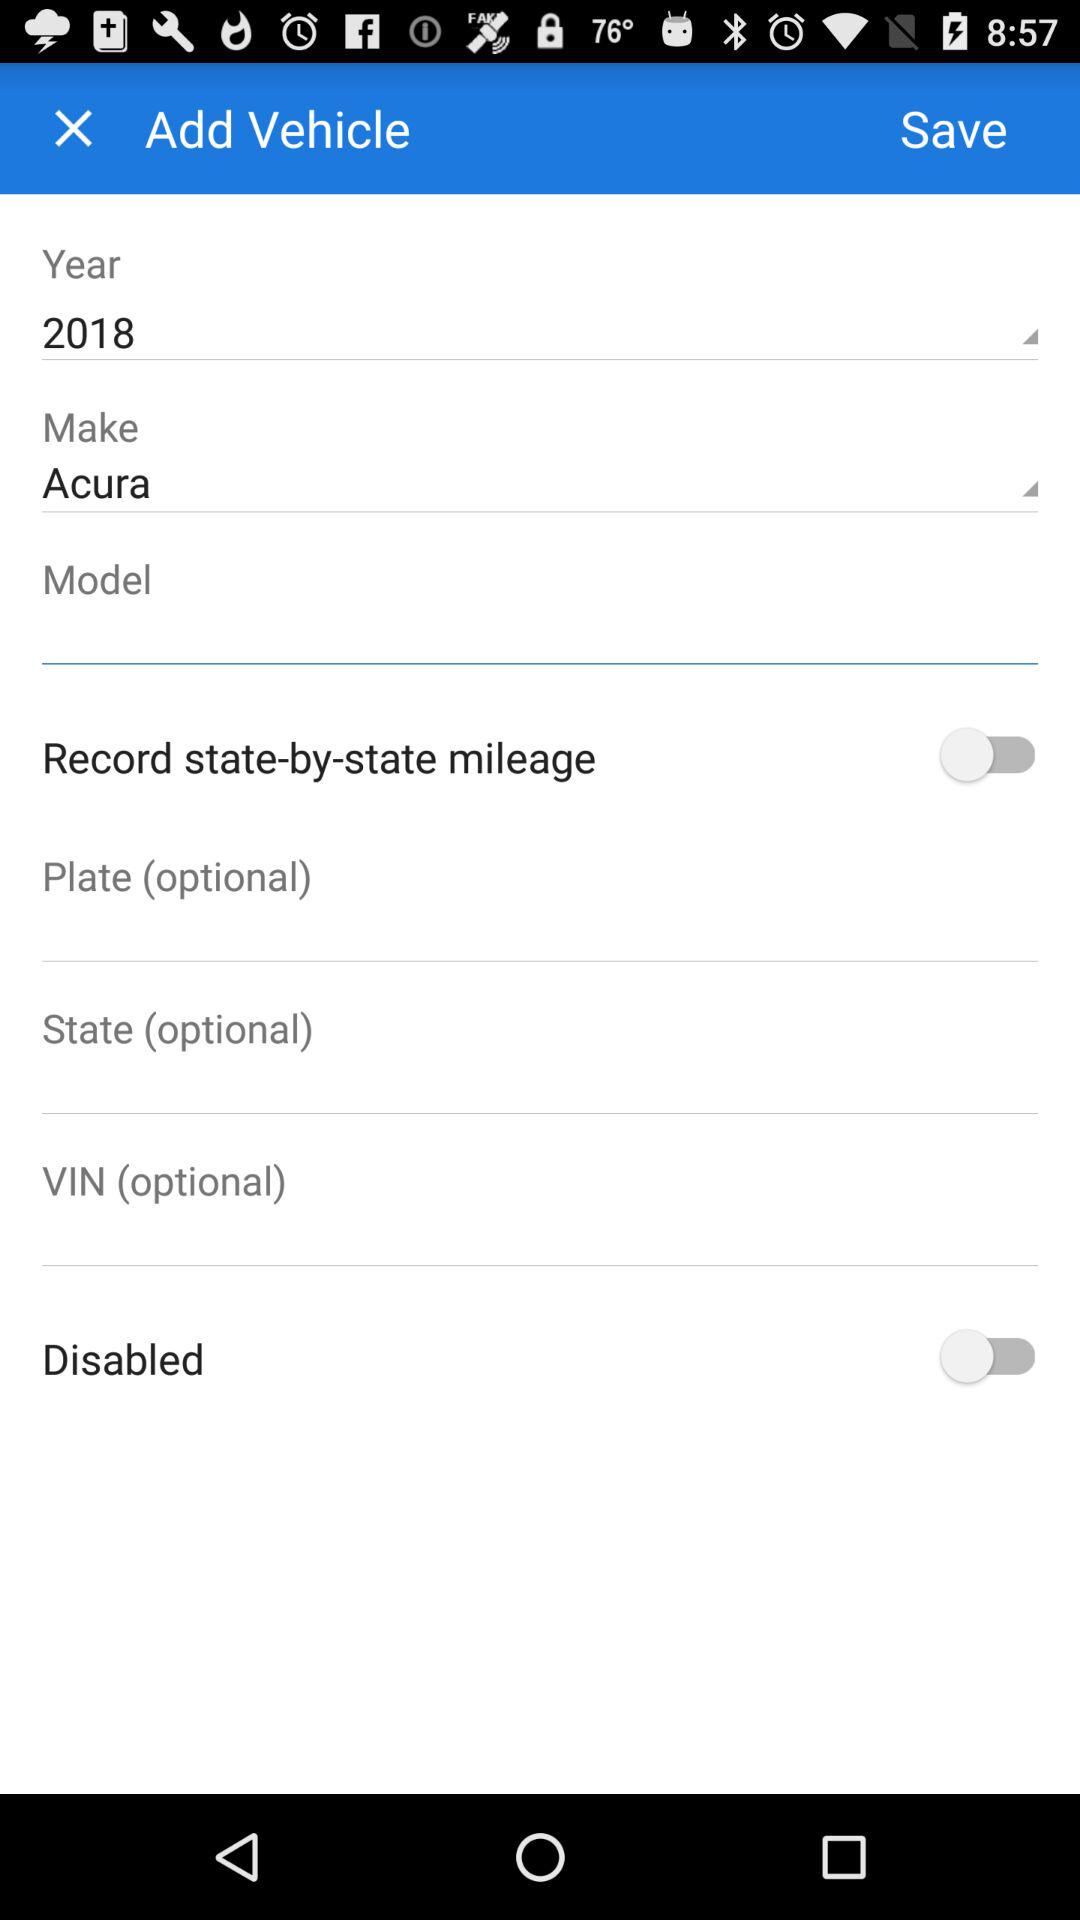How many text inputs are there that are optional?
Answer the question using a single word or phrase. 3 